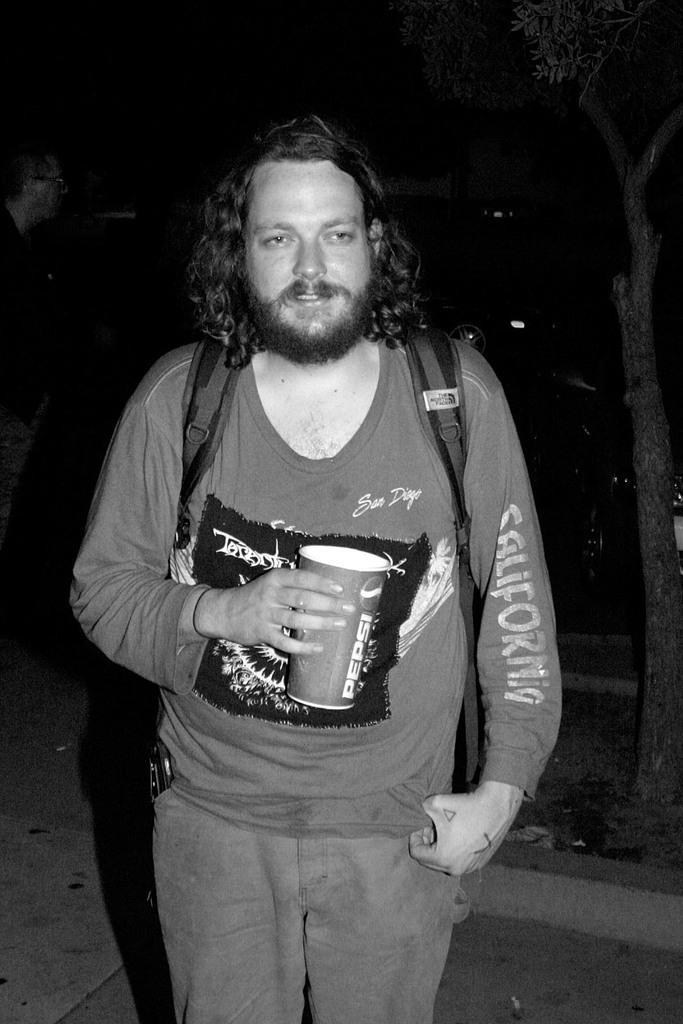In one or two sentences, can you explain what this image depicts? This is a black and white image in this image, in the center there is one person who is standing and he is holding a cup. And in the background there are some trees and one person, at the bottom there is a walkway. 